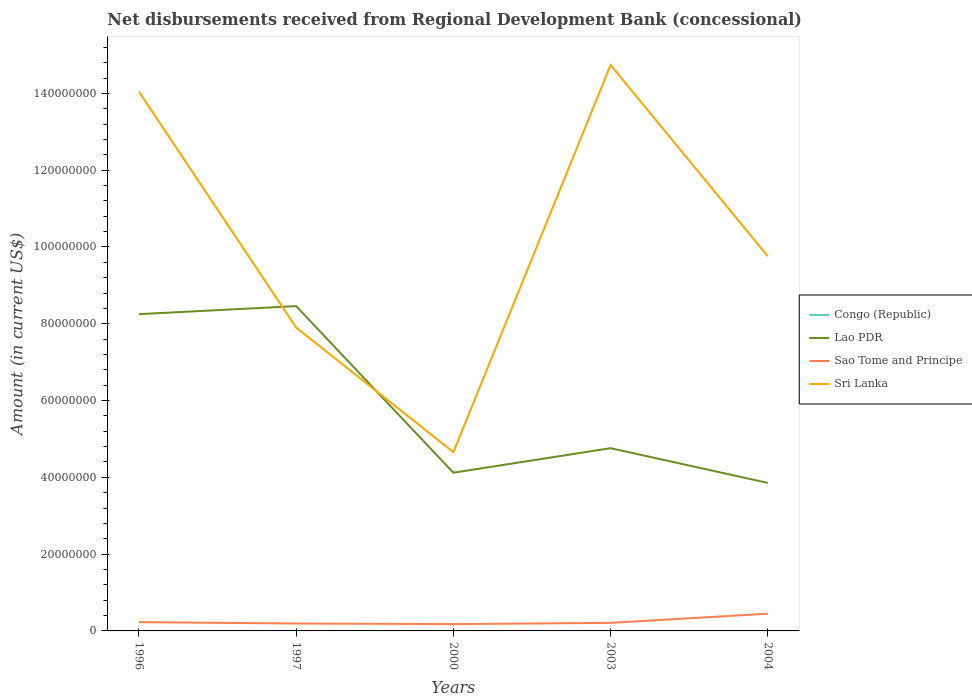Does the line corresponding to Congo (Republic) intersect with the line corresponding to Lao PDR?
Your answer should be very brief. No. Is the number of lines equal to the number of legend labels?
Your response must be concise. No. Across all years, what is the maximum amount of disbursements received from Regional Development Bank in Sao Tome and Principe?
Offer a very short reply. 1.77e+06. What is the total amount of disbursements received from Regional Development Bank in Sao Tome and Principe in the graph?
Ensure brevity in your answer.  -1.67e+05. What is the difference between the highest and the second highest amount of disbursements received from Regional Development Bank in Lao PDR?
Make the answer very short. 4.60e+07. How many lines are there?
Give a very brief answer. 3. How many years are there in the graph?
Provide a succinct answer. 5. What is the difference between two consecutive major ticks on the Y-axis?
Ensure brevity in your answer.  2.00e+07. Are the values on the major ticks of Y-axis written in scientific E-notation?
Keep it short and to the point. No. Where does the legend appear in the graph?
Provide a short and direct response. Center right. How many legend labels are there?
Offer a very short reply. 4. What is the title of the graph?
Make the answer very short. Net disbursements received from Regional Development Bank (concessional). Does "Lesotho" appear as one of the legend labels in the graph?
Your response must be concise. No. What is the label or title of the X-axis?
Give a very brief answer. Years. What is the Amount (in current US$) in Congo (Republic) in 1996?
Ensure brevity in your answer.  0. What is the Amount (in current US$) of Lao PDR in 1996?
Offer a terse response. 8.25e+07. What is the Amount (in current US$) of Sao Tome and Principe in 1996?
Offer a terse response. 2.28e+06. What is the Amount (in current US$) of Sri Lanka in 1996?
Provide a succinct answer. 1.40e+08. What is the Amount (in current US$) in Congo (Republic) in 1997?
Offer a very short reply. 0. What is the Amount (in current US$) of Lao PDR in 1997?
Provide a short and direct response. 8.46e+07. What is the Amount (in current US$) of Sao Tome and Principe in 1997?
Provide a short and direct response. 1.93e+06. What is the Amount (in current US$) in Sri Lanka in 1997?
Provide a short and direct response. 7.90e+07. What is the Amount (in current US$) of Congo (Republic) in 2000?
Offer a terse response. 0. What is the Amount (in current US$) of Lao PDR in 2000?
Ensure brevity in your answer.  4.12e+07. What is the Amount (in current US$) of Sao Tome and Principe in 2000?
Make the answer very short. 1.77e+06. What is the Amount (in current US$) of Sri Lanka in 2000?
Make the answer very short. 4.66e+07. What is the Amount (in current US$) in Lao PDR in 2003?
Your answer should be compact. 4.76e+07. What is the Amount (in current US$) in Sao Tome and Principe in 2003?
Ensure brevity in your answer.  2.10e+06. What is the Amount (in current US$) of Sri Lanka in 2003?
Offer a terse response. 1.47e+08. What is the Amount (in current US$) of Lao PDR in 2004?
Provide a succinct answer. 3.86e+07. What is the Amount (in current US$) in Sao Tome and Principe in 2004?
Give a very brief answer. 4.48e+06. What is the Amount (in current US$) in Sri Lanka in 2004?
Your answer should be compact. 9.76e+07. Across all years, what is the maximum Amount (in current US$) in Lao PDR?
Your response must be concise. 8.46e+07. Across all years, what is the maximum Amount (in current US$) in Sao Tome and Principe?
Give a very brief answer. 4.48e+06. Across all years, what is the maximum Amount (in current US$) in Sri Lanka?
Your response must be concise. 1.47e+08. Across all years, what is the minimum Amount (in current US$) in Lao PDR?
Make the answer very short. 3.86e+07. Across all years, what is the minimum Amount (in current US$) of Sao Tome and Principe?
Provide a short and direct response. 1.77e+06. Across all years, what is the minimum Amount (in current US$) in Sri Lanka?
Provide a succinct answer. 4.66e+07. What is the total Amount (in current US$) of Congo (Republic) in the graph?
Give a very brief answer. 0. What is the total Amount (in current US$) in Lao PDR in the graph?
Your answer should be very brief. 2.94e+08. What is the total Amount (in current US$) in Sao Tome and Principe in the graph?
Offer a terse response. 1.26e+07. What is the total Amount (in current US$) in Sri Lanka in the graph?
Your answer should be compact. 5.11e+08. What is the difference between the Amount (in current US$) of Lao PDR in 1996 and that in 1997?
Your answer should be very brief. -2.10e+06. What is the difference between the Amount (in current US$) of Sao Tome and Principe in 1996 and that in 1997?
Offer a very short reply. 3.51e+05. What is the difference between the Amount (in current US$) of Sri Lanka in 1996 and that in 1997?
Ensure brevity in your answer.  6.14e+07. What is the difference between the Amount (in current US$) in Lao PDR in 1996 and that in 2000?
Offer a terse response. 4.13e+07. What is the difference between the Amount (in current US$) in Sao Tome and Principe in 1996 and that in 2000?
Keep it short and to the point. 5.13e+05. What is the difference between the Amount (in current US$) in Sri Lanka in 1996 and that in 2000?
Provide a succinct answer. 9.39e+07. What is the difference between the Amount (in current US$) of Lao PDR in 1996 and that in 2003?
Make the answer very short. 3.49e+07. What is the difference between the Amount (in current US$) in Sao Tome and Principe in 1996 and that in 2003?
Your answer should be very brief. 1.84e+05. What is the difference between the Amount (in current US$) in Sri Lanka in 1996 and that in 2003?
Your answer should be compact. -6.95e+06. What is the difference between the Amount (in current US$) in Lao PDR in 1996 and that in 2004?
Provide a short and direct response. 4.40e+07. What is the difference between the Amount (in current US$) in Sao Tome and Principe in 1996 and that in 2004?
Offer a terse response. -2.20e+06. What is the difference between the Amount (in current US$) of Sri Lanka in 1996 and that in 2004?
Make the answer very short. 4.29e+07. What is the difference between the Amount (in current US$) of Lao PDR in 1997 and that in 2000?
Provide a short and direct response. 4.34e+07. What is the difference between the Amount (in current US$) of Sao Tome and Principe in 1997 and that in 2000?
Your response must be concise. 1.62e+05. What is the difference between the Amount (in current US$) of Sri Lanka in 1997 and that in 2000?
Provide a short and direct response. 3.25e+07. What is the difference between the Amount (in current US$) in Lao PDR in 1997 and that in 2003?
Provide a succinct answer. 3.70e+07. What is the difference between the Amount (in current US$) in Sao Tome and Principe in 1997 and that in 2003?
Ensure brevity in your answer.  -1.67e+05. What is the difference between the Amount (in current US$) of Sri Lanka in 1997 and that in 2003?
Your response must be concise. -6.84e+07. What is the difference between the Amount (in current US$) of Lao PDR in 1997 and that in 2004?
Give a very brief answer. 4.60e+07. What is the difference between the Amount (in current US$) of Sao Tome and Principe in 1997 and that in 2004?
Your answer should be compact. -2.55e+06. What is the difference between the Amount (in current US$) in Sri Lanka in 1997 and that in 2004?
Keep it short and to the point. -1.86e+07. What is the difference between the Amount (in current US$) of Lao PDR in 2000 and that in 2003?
Your answer should be compact. -6.38e+06. What is the difference between the Amount (in current US$) in Sao Tome and Principe in 2000 and that in 2003?
Your answer should be compact. -3.29e+05. What is the difference between the Amount (in current US$) in Sri Lanka in 2000 and that in 2003?
Offer a terse response. -1.01e+08. What is the difference between the Amount (in current US$) of Lao PDR in 2000 and that in 2004?
Offer a terse response. 2.66e+06. What is the difference between the Amount (in current US$) of Sao Tome and Principe in 2000 and that in 2004?
Keep it short and to the point. -2.71e+06. What is the difference between the Amount (in current US$) in Sri Lanka in 2000 and that in 2004?
Provide a short and direct response. -5.10e+07. What is the difference between the Amount (in current US$) in Lao PDR in 2003 and that in 2004?
Give a very brief answer. 9.04e+06. What is the difference between the Amount (in current US$) in Sao Tome and Principe in 2003 and that in 2004?
Your answer should be compact. -2.38e+06. What is the difference between the Amount (in current US$) of Sri Lanka in 2003 and that in 2004?
Offer a terse response. 4.98e+07. What is the difference between the Amount (in current US$) in Lao PDR in 1996 and the Amount (in current US$) in Sao Tome and Principe in 1997?
Make the answer very short. 8.06e+07. What is the difference between the Amount (in current US$) in Lao PDR in 1996 and the Amount (in current US$) in Sri Lanka in 1997?
Make the answer very short. 3.49e+06. What is the difference between the Amount (in current US$) of Sao Tome and Principe in 1996 and the Amount (in current US$) of Sri Lanka in 1997?
Give a very brief answer. -7.67e+07. What is the difference between the Amount (in current US$) in Lao PDR in 1996 and the Amount (in current US$) in Sao Tome and Principe in 2000?
Your answer should be compact. 8.07e+07. What is the difference between the Amount (in current US$) in Lao PDR in 1996 and the Amount (in current US$) in Sri Lanka in 2000?
Your response must be concise. 3.59e+07. What is the difference between the Amount (in current US$) in Sao Tome and Principe in 1996 and the Amount (in current US$) in Sri Lanka in 2000?
Make the answer very short. -4.43e+07. What is the difference between the Amount (in current US$) in Lao PDR in 1996 and the Amount (in current US$) in Sao Tome and Principe in 2003?
Give a very brief answer. 8.04e+07. What is the difference between the Amount (in current US$) of Lao PDR in 1996 and the Amount (in current US$) of Sri Lanka in 2003?
Offer a terse response. -6.49e+07. What is the difference between the Amount (in current US$) of Sao Tome and Principe in 1996 and the Amount (in current US$) of Sri Lanka in 2003?
Ensure brevity in your answer.  -1.45e+08. What is the difference between the Amount (in current US$) in Lao PDR in 1996 and the Amount (in current US$) in Sao Tome and Principe in 2004?
Keep it short and to the point. 7.80e+07. What is the difference between the Amount (in current US$) of Lao PDR in 1996 and the Amount (in current US$) of Sri Lanka in 2004?
Make the answer very short. -1.51e+07. What is the difference between the Amount (in current US$) in Sao Tome and Principe in 1996 and the Amount (in current US$) in Sri Lanka in 2004?
Give a very brief answer. -9.53e+07. What is the difference between the Amount (in current US$) in Lao PDR in 1997 and the Amount (in current US$) in Sao Tome and Principe in 2000?
Offer a very short reply. 8.28e+07. What is the difference between the Amount (in current US$) of Lao PDR in 1997 and the Amount (in current US$) of Sri Lanka in 2000?
Provide a succinct answer. 3.80e+07. What is the difference between the Amount (in current US$) in Sao Tome and Principe in 1997 and the Amount (in current US$) in Sri Lanka in 2000?
Your answer should be compact. -4.46e+07. What is the difference between the Amount (in current US$) in Lao PDR in 1997 and the Amount (in current US$) in Sao Tome and Principe in 2003?
Your response must be concise. 8.25e+07. What is the difference between the Amount (in current US$) of Lao PDR in 1997 and the Amount (in current US$) of Sri Lanka in 2003?
Your answer should be very brief. -6.28e+07. What is the difference between the Amount (in current US$) in Sao Tome and Principe in 1997 and the Amount (in current US$) in Sri Lanka in 2003?
Keep it short and to the point. -1.45e+08. What is the difference between the Amount (in current US$) in Lao PDR in 1997 and the Amount (in current US$) in Sao Tome and Principe in 2004?
Make the answer very short. 8.01e+07. What is the difference between the Amount (in current US$) in Lao PDR in 1997 and the Amount (in current US$) in Sri Lanka in 2004?
Offer a terse response. -1.30e+07. What is the difference between the Amount (in current US$) in Sao Tome and Principe in 1997 and the Amount (in current US$) in Sri Lanka in 2004?
Your answer should be very brief. -9.56e+07. What is the difference between the Amount (in current US$) in Lao PDR in 2000 and the Amount (in current US$) in Sao Tome and Principe in 2003?
Offer a terse response. 3.91e+07. What is the difference between the Amount (in current US$) of Lao PDR in 2000 and the Amount (in current US$) of Sri Lanka in 2003?
Your answer should be very brief. -1.06e+08. What is the difference between the Amount (in current US$) of Sao Tome and Principe in 2000 and the Amount (in current US$) of Sri Lanka in 2003?
Your answer should be very brief. -1.46e+08. What is the difference between the Amount (in current US$) in Lao PDR in 2000 and the Amount (in current US$) in Sao Tome and Principe in 2004?
Make the answer very short. 3.67e+07. What is the difference between the Amount (in current US$) of Lao PDR in 2000 and the Amount (in current US$) of Sri Lanka in 2004?
Make the answer very short. -5.64e+07. What is the difference between the Amount (in current US$) in Sao Tome and Principe in 2000 and the Amount (in current US$) in Sri Lanka in 2004?
Your response must be concise. -9.58e+07. What is the difference between the Amount (in current US$) of Lao PDR in 2003 and the Amount (in current US$) of Sao Tome and Principe in 2004?
Provide a short and direct response. 4.31e+07. What is the difference between the Amount (in current US$) in Lao PDR in 2003 and the Amount (in current US$) in Sri Lanka in 2004?
Offer a terse response. -5.00e+07. What is the difference between the Amount (in current US$) of Sao Tome and Principe in 2003 and the Amount (in current US$) of Sri Lanka in 2004?
Offer a very short reply. -9.55e+07. What is the average Amount (in current US$) in Congo (Republic) per year?
Offer a very short reply. 0. What is the average Amount (in current US$) of Lao PDR per year?
Your response must be concise. 5.89e+07. What is the average Amount (in current US$) in Sao Tome and Principe per year?
Provide a short and direct response. 2.52e+06. What is the average Amount (in current US$) of Sri Lanka per year?
Provide a succinct answer. 1.02e+08. In the year 1996, what is the difference between the Amount (in current US$) of Lao PDR and Amount (in current US$) of Sao Tome and Principe?
Offer a terse response. 8.02e+07. In the year 1996, what is the difference between the Amount (in current US$) in Lao PDR and Amount (in current US$) in Sri Lanka?
Provide a succinct answer. -5.79e+07. In the year 1996, what is the difference between the Amount (in current US$) of Sao Tome and Principe and Amount (in current US$) of Sri Lanka?
Your answer should be compact. -1.38e+08. In the year 1997, what is the difference between the Amount (in current US$) in Lao PDR and Amount (in current US$) in Sao Tome and Principe?
Your answer should be compact. 8.27e+07. In the year 1997, what is the difference between the Amount (in current US$) of Lao PDR and Amount (in current US$) of Sri Lanka?
Your answer should be compact. 5.58e+06. In the year 1997, what is the difference between the Amount (in current US$) of Sao Tome and Principe and Amount (in current US$) of Sri Lanka?
Offer a very short reply. -7.71e+07. In the year 2000, what is the difference between the Amount (in current US$) of Lao PDR and Amount (in current US$) of Sao Tome and Principe?
Your answer should be very brief. 3.94e+07. In the year 2000, what is the difference between the Amount (in current US$) in Lao PDR and Amount (in current US$) in Sri Lanka?
Your answer should be compact. -5.35e+06. In the year 2000, what is the difference between the Amount (in current US$) of Sao Tome and Principe and Amount (in current US$) of Sri Lanka?
Make the answer very short. -4.48e+07. In the year 2003, what is the difference between the Amount (in current US$) in Lao PDR and Amount (in current US$) in Sao Tome and Principe?
Offer a very short reply. 4.55e+07. In the year 2003, what is the difference between the Amount (in current US$) in Lao PDR and Amount (in current US$) in Sri Lanka?
Provide a short and direct response. -9.98e+07. In the year 2003, what is the difference between the Amount (in current US$) in Sao Tome and Principe and Amount (in current US$) in Sri Lanka?
Keep it short and to the point. -1.45e+08. In the year 2004, what is the difference between the Amount (in current US$) in Lao PDR and Amount (in current US$) in Sao Tome and Principe?
Provide a succinct answer. 3.41e+07. In the year 2004, what is the difference between the Amount (in current US$) of Lao PDR and Amount (in current US$) of Sri Lanka?
Give a very brief answer. -5.90e+07. In the year 2004, what is the difference between the Amount (in current US$) in Sao Tome and Principe and Amount (in current US$) in Sri Lanka?
Offer a terse response. -9.31e+07. What is the ratio of the Amount (in current US$) of Lao PDR in 1996 to that in 1997?
Your response must be concise. 0.98. What is the ratio of the Amount (in current US$) of Sao Tome and Principe in 1996 to that in 1997?
Offer a terse response. 1.18. What is the ratio of the Amount (in current US$) of Sri Lanka in 1996 to that in 1997?
Keep it short and to the point. 1.78. What is the ratio of the Amount (in current US$) in Lao PDR in 1996 to that in 2000?
Offer a terse response. 2. What is the ratio of the Amount (in current US$) in Sao Tome and Principe in 1996 to that in 2000?
Your response must be concise. 1.29. What is the ratio of the Amount (in current US$) of Sri Lanka in 1996 to that in 2000?
Your response must be concise. 3.02. What is the ratio of the Amount (in current US$) in Lao PDR in 1996 to that in 2003?
Offer a very short reply. 1.73. What is the ratio of the Amount (in current US$) of Sao Tome and Principe in 1996 to that in 2003?
Keep it short and to the point. 1.09. What is the ratio of the Amount (in current US$) in Sri Lanka in 1996 to that in 2003?
Make the answer very short. 0.95. What is the ratio of the Amount (in current US$) of Lao PDR in 1996 to that in 2004?
Your answer should be compact. 2.14. What is the ratio of the Amount (in current US$) of Sao Tome and Principe in 1996 to that in 2004?
Ensure brevity in your answer.  0.51. What is the ratio of the Amount (in current US$) of Sri Lanka in 1996 to that in 2004?
Your answer should be compact. 1.44. What is the ratio of the Amount (in current US$) of Lao PDR in 1997 to that in 2000?
Make the answer very short. 2.05. What is the ratio of the Amount (in current US$) in Sao Tome and Principe in 1997 to that in 2000?
Offer a very short reply. 1.09. What is the ratio of the Amount (in current US$) in Sri Lanka in 1997 to that in 2000?
Your answer should be very brief. 1.7. What is the ratio of the Amount (in current US$) of Lao PDR in 1997 to that in 2003?
Keep it short and to the point. 1.78. What is the ratio of the Amount (in current US$) of Sao Tome and Principe in 1997 to that in 2003?
Your answer should be very brief. 0.92. What is the ratio of the Amount (in current US$) of Sri Lanka in 1997 to that in 2003?
Ensure brevity in your answer.  0.54. What is the ratio of the Amount (in current US$) in Lao PDR in 1997 to that in 2004?
Keep it short and to the point. 2.19. What is the ratio of the Amount (in current US$) of Sao Tome and Principe in 1997 to that in 2004?
Ensure brevity in your answer.  0.43. What is the ratio of the Amount (in current US$) of Sri Lanka in 1997 to that in 2004?
Offer a very short reply. 0.81. What is the ratio of the Amount (in current US$) in Lao PDR in 2000 to that in 2003?
Offer a very short reply. 0.87. What is the ratio of the Amount (in current US$) in Sao Tome and Principe in 2000 to that in 2003?
Your answer should be compact. 0.84. What is the ratio of the Amount (in current US$) in Sri Lanka in 2000 to that in 2003?
Keep it short and to the point. 0.32. What is the ratio of the Amount (in current US$) in Lao PDR in 2000 to that in 2004?
Ensure brevity in your answer.  1.07. What is the ratio of the Amount (in current US$) in Sao Tome and Principe in 2000 to that in 2004?
Your response must be concise. 0.4. What is the ratio of the Amount (in current US$) in Sri Lanka in 2000 to that in 2004?
Keep it short and to the point. 0.48. What is the ratio of the Amount (in current US$) in Lao PDR in 2003 to that in 2004?
Provide a short and direct response. 1.23. What is the ratio of the Amount (in current US$) of Sao Tome and Principe in 2003 to that in 2004?
Keep it short and to the point. 0.47. What is the ratio of the Amount (in current US$) of Sri Lanka in 2003 to that in 2004?
Make the answer very short. 1.51. What is the difference between the highest and the second highest Amount (in current US$) of Lao PDR?
Your answer should be very brief. 2.10e+06. What is the difference between the highest and the second highest Amount (in current US$) of Sao Tome and Principe?
Your response must be concise. 2.20e+06. What is the difference between the highest and the second highest Amount (in current US$) in Sri Lanka?
Provide a succinct answer. 6.95e+06. What is the difference between the highest and the lowest Amount (in current US$) in Lao PDR?
Keep it short and to the point. 4.60e+07. What is the difference between the highest and the lowest Amount (in current US$) of Sao Tome and Principe?
Provide a short and direct response. 2.71e+06. What is the difference between the highest and the lowest Amount (in current US$) of Sri Lanka?
Ensure brevity in your answer.  1.01e+08. 